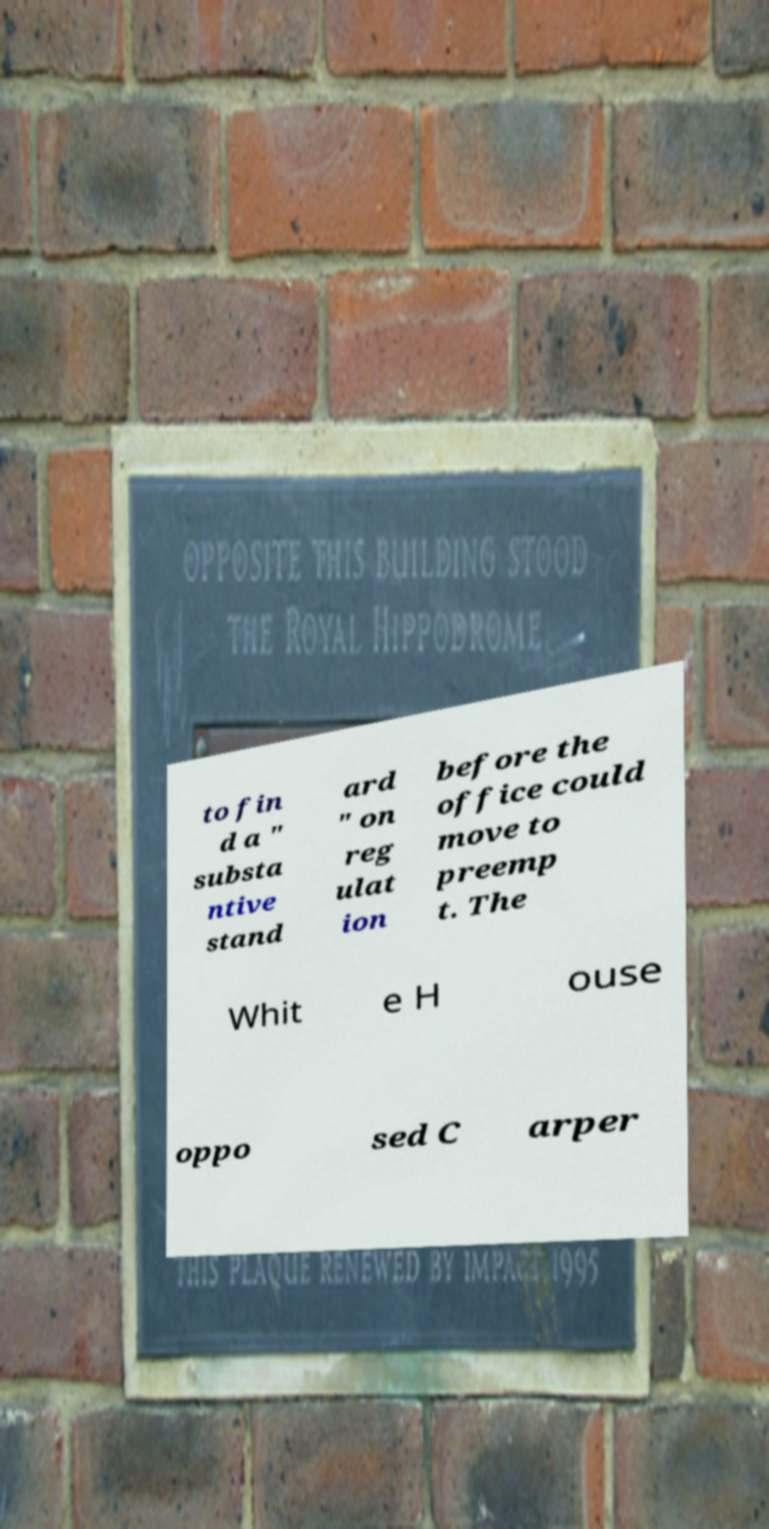Can you read and provide the text displayed in the image?This photo seems to have some interesting text. Can you extract and type it out for me? to fin d a " substa ntive stand ard " on reg ulat ion before the office could move to preemp t. The Whit e H ouse oppo sed C arper 